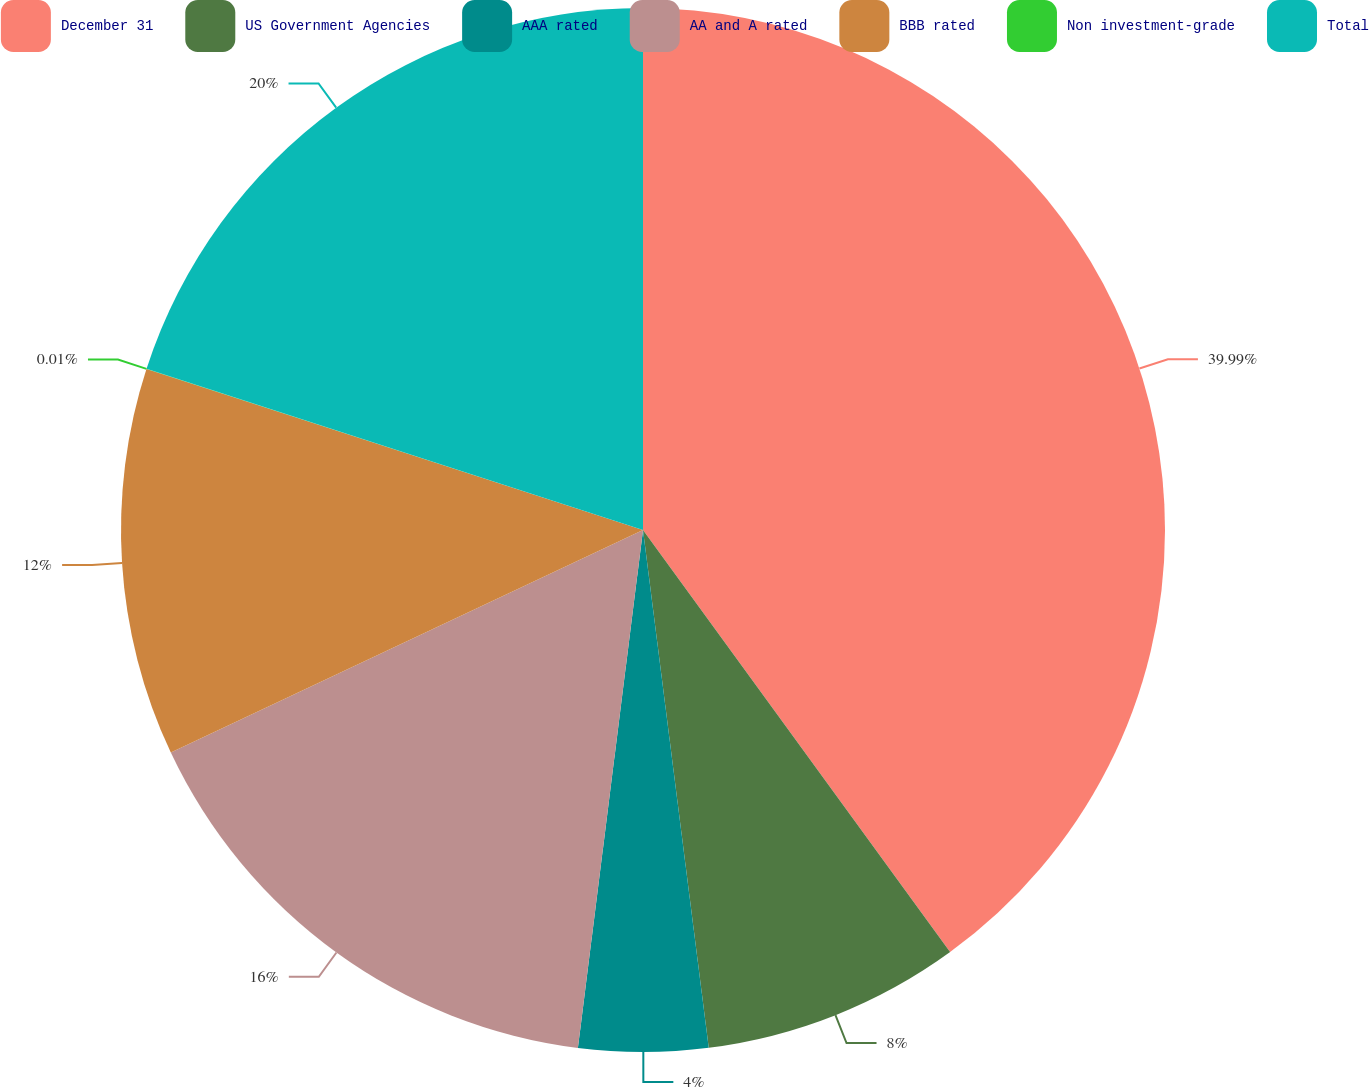<chart> <loc_0><loc_0><loc_500><loc_500><pie_chart><fcel>December 31<fcel>US Government Agencies<fcel>AAA rated<fcel>AA and A rated<fcel>BBB rated<fcel>Non investment-grade<fcel>Total<nl><fcel>39.99%<fcel>8.0%<fcel>4.0%<fcel>16.0%<fcel>12.0%<fcel>0.01%<fcel>20.0%<nl></chart> 